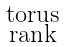Convert formula to latex. <formula><loc_0><loc_0><loc_500><loc_500>\begin{smallmatrix} \text {torus} \\ \text {rank} \end{smallmatrix}</formula> 